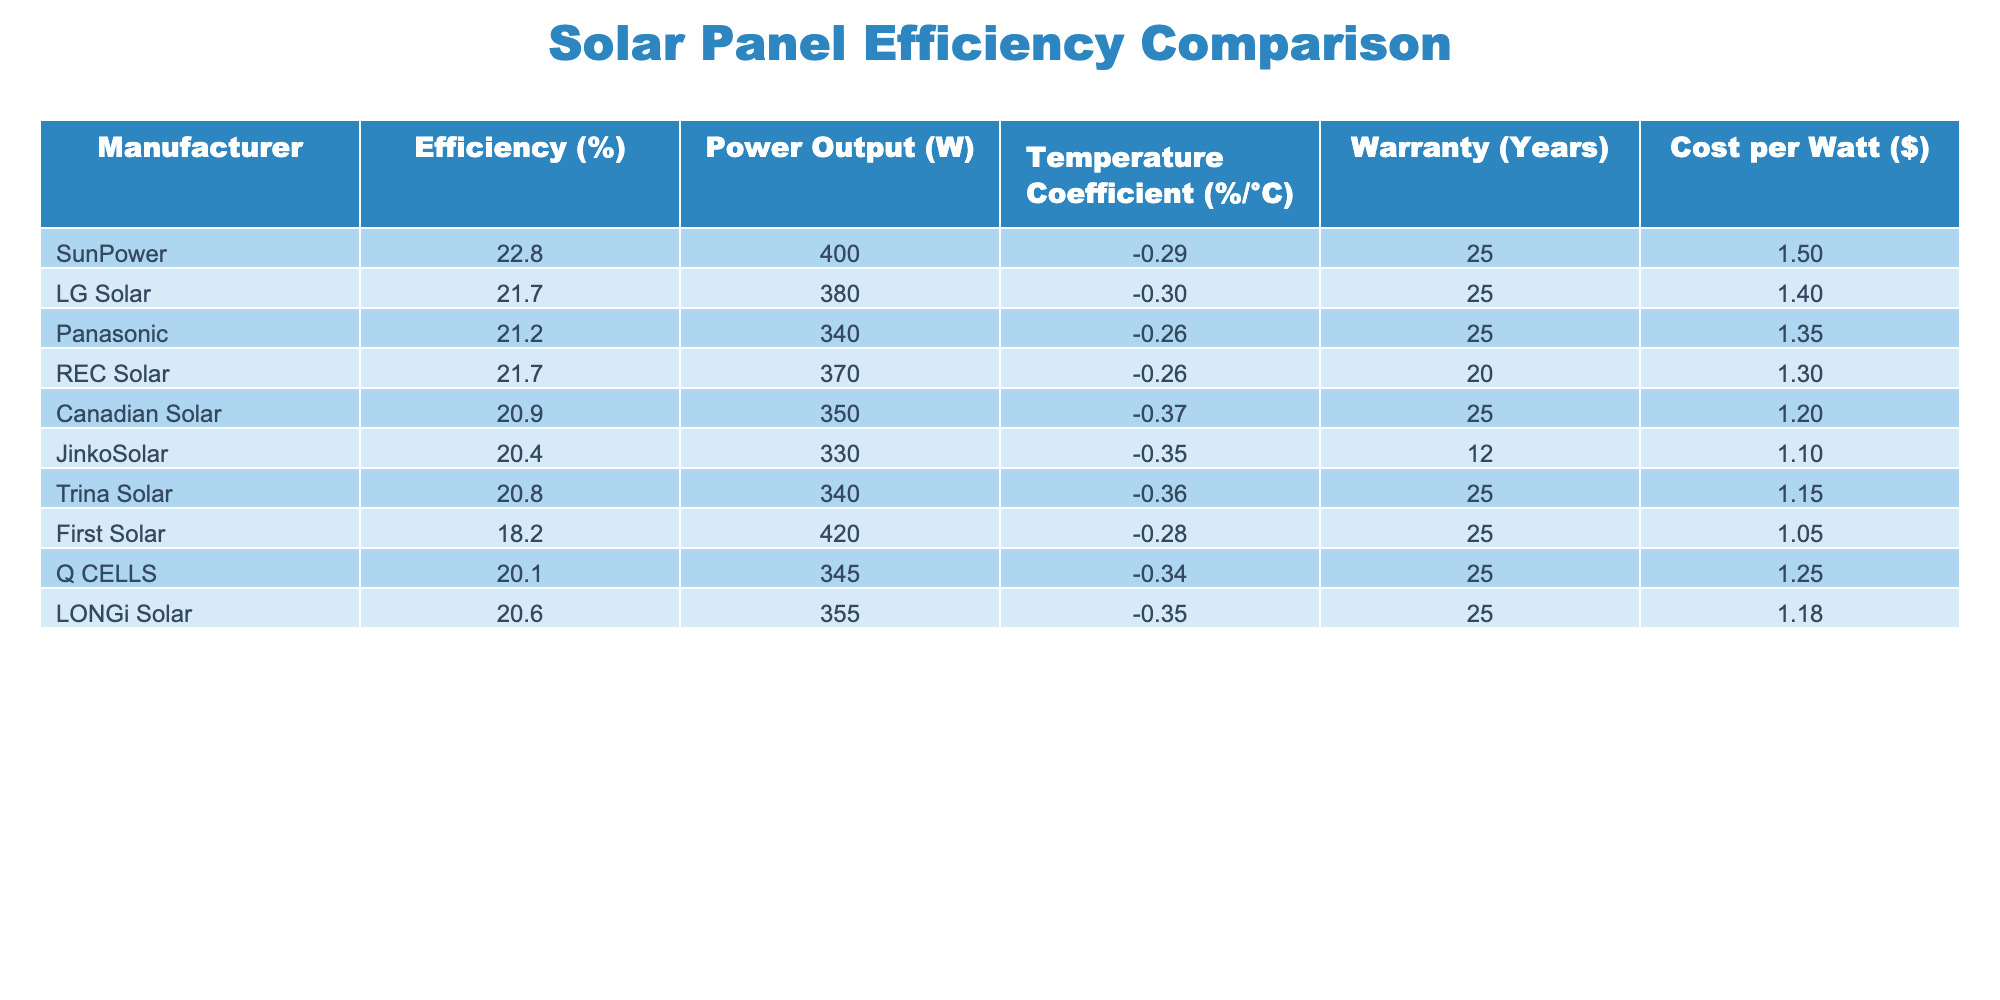What is the efficiency percentage of SunPower solar panels? The table lists the efficiency percentage for each manufacturer. For SunPower, the efficiency is explicitly stated in the table as 22.8%.
Answer: 22.8% Which manufacturer offers the lowest cost per watt? By reviewing the 'Cost per Watt' column in the table, Canadian Solar offers the lowest cost per watt at $1.20.
Answer: Canadian Solar What is the temperature coefficient of Panasonic solar panels? The temperature coefficient for Panasonic is clearly listed in the table. It is -0.26%/°C according to the information provided.
Answer: -0.26%/°C What is the average warranty period for the manufacturers listed? To find the average warranty, sum the warranty years for all manufacturers (25+25+25+20+25+12+25+25+25 = 187). There are 9 manufacturers, so the average warranty is 187/9 = 20.78 years, rounded to two decimal places.
Answer: 20.78 years Do all manufacturers have a temperature coefficient worse than -0.30%/°C? By checking the temperature coefficient values, long of those listed, we find Panasonic (-0.26) and REC Solar (-0.26) have values better than -0.30%. Therefore, the answer is no, not all have worse values.
Answer: No Which manufacturer has the highest power output, and what is it? By scanning the 'Power Output' column, First Solar has the highest power output listed at 420 Watts.
Answer: First Solar, 420 Watts If we classify solar panels based on efficiency, how many have efficiency above 21%? From the efficiency values, the manufacturers that have efficiency above 21% are SunPower (22.8%), LG Solar (21.7%), and REC Solar (21.7%). Thus, there are a total of three manufacturers.
Answer: 3 Is LG Solar more efficient than JinkoSolar? According to the efficiency values, LG Solar has an efficiency of 21.7%, while JinkoSolar has 20.4%. Since 21.7 is greater than 20.4, LG Solar is indeed more efficient.
Answer: Yes What is the difference in efficiency between the most and least efficient solar panels? The most efficient panels are SunPower at 22.8% and the least efficient are First Solar at 18.2%. Thus, the difference is calculated as 22.8% - 18.2% = 4.6%.
Answer: 4.6% 